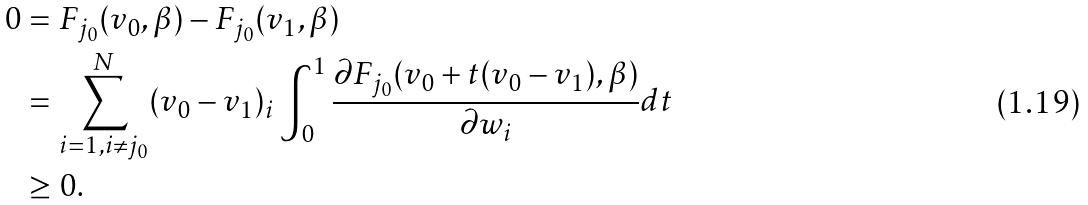<formula> <loc_0><loc_0><loc_500><loc_500>0 & = F _ { j _ { 0 } } ( v _ { 0 } , \beta ) - F _ { j _ { 0 } } ( v _ { 1 } , \beta ) \\ & = \sum _ { i = 1 , i \ne j _ { 0 } } ^ { N } ( v _ { 0 } - v _ { 1 } ) _ { i } \int _ { 0 } ^ { 1 } \frac { \partial F _ { j _ { 0 } } ( v _ { 0 } + t ( v _ { 0 } - v _ { 1 } ) , \beta ) } { \partial w _ { i } } d t \\ & \geq 0 .</formula> 